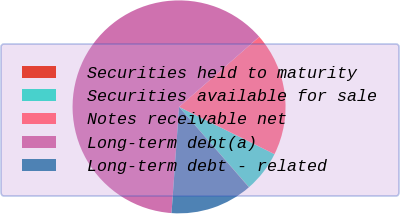<chart> <loc_0><loc_0><loc_500><loc_500><pie_chart><fcel>Securities held to maturity<fcel>Securities available for sale<fcel>Notes receivable net<fcel>Long-term debt(a)<fcel>Long-term debt - related<nl><fcel>0.03%<fcel>6.27%<fcel>18.75%<fcel>62.44%<fcel>12.51%<nl></chart> 